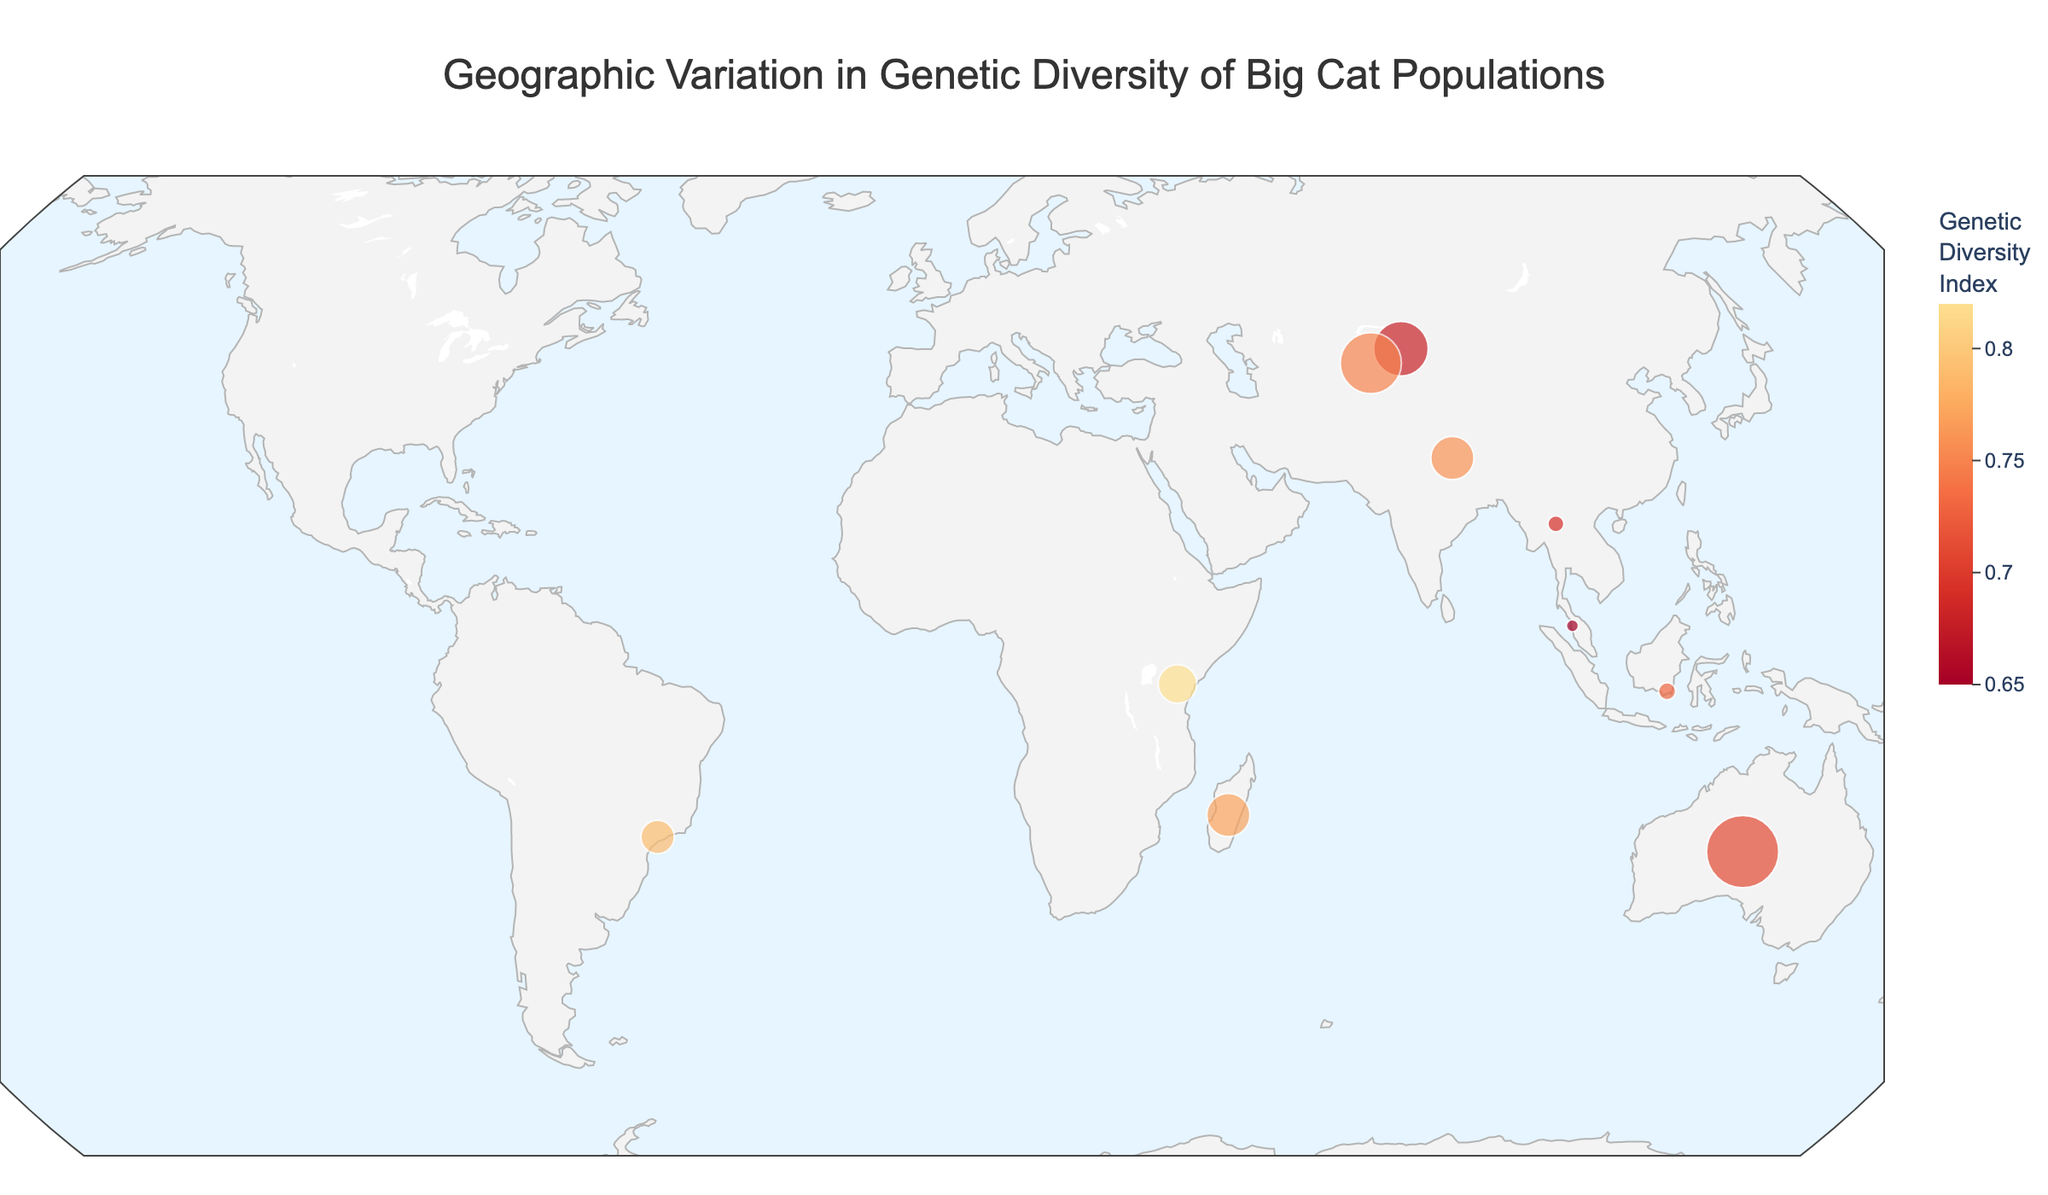What is the title of the figure? The title is usually displayed at the top of the figure, indicating what the plot represents. Here, it is "Geographic Variation in Genetic Diversity of Big Cat Populations."
Answer: Geographic Variation in Genetic Diversity of Big Cat Populations How many species of big cats are represented on the map? By examining the plot, one can count the distinct points with different species names. There are 10 species represented.
Answer: 10 Which species has the highest Genetic Diversity Index? Look for the species with the highest color intensity, corresponding to the highest index mentioned in the hover data. The African Lion has the highest index at 0.82.
Answer: African Lion What is the Population Size of the Cheetah? Locate the Cheetah on the map (marked at Longitude 131.5 and Latitude -25.5). The hover data or annotations will show Population Size: 7000.
Answer: 7000 Which species are located in Asia? Identify the species positioned in the Asian region of the map. Bengal Tiger, Snow Leopard, Malayan Tiger, Indochinese Tiger, and Sunda Clouded Leopard are located in Asia.
Answer: Bengal Tiger, Snow Leopard, Malayan Tiger, Indochinese Tiger, Sunda Clouded Leopard What is the difference in Genetic Diversity Index between the Bengal Tiger and the Malayan Tiger? Find the Genetic Diversity Index for both species from the hover data. Subtract the lower index (Malayan Tiger: 0.65) from the higher index (Bengal Tiger: 0.76). The difference is 0.11.
Answer: 0.11 Which species has the largest population size, and what is its size? Find the species with the largest bubble size on the map, indicating the highest population. The Cheetah is the largest, with a population size of 7000.
Answer: Cheetah, 7000 Which species has the smallest population size, and what is its Genetic Diversity Index? Look for the smallest bubble on the map, which represents the smallest population. The Malayan Tiger has the smallest population size (200) and a Genetic Diversity Index of 0.65.
Answer: Malayan Tiger, 0.65 How does the Genetic Diversity Index of the Eurasian Lynx compare to that of the Fosa? Compare the Genetic Diversity Index of both species noted in their respective hover data. Eurasian Lynx has an index of 0.75, while Fosa has an index of 0.77. Fosa's index is slightly higher.
Answer: Fosa > Eurasian Lynx What is the average Genetic Diversity Index of all big cat populations shown? Add the Genetic Diversity Index values of all the species and divide by the number of species (10). Calculations: (0.82 + 0.76 + 0.79 + 0.68 + 0.71 + 0.65 + 0.73 + 0.69 + 0.77 + 0.75)/10 = 7.35/10 = 0.735.
Answer: 0.735 